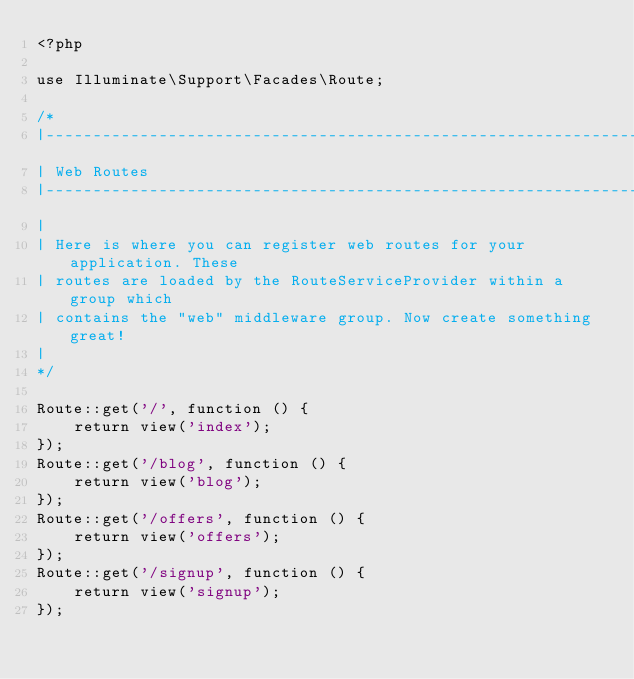<code> <loc_0><loc_0><loc_500><loc_500><_PHP_><?php

use Illuminate\Support\Facades\Route;

/*
|--------------------------------------------------------------------------
| Web Routes
|--------------------------------------------------------------------------
|
| Here is where you can register web routes for your application. These
| routes are loaded by the RouteServiceProvider within a group which
| contains the "web" middleware group. Now create something great!
|
*/

Route::get('/', function () {
    return view('index');
});
Route::get('/blog', function () {
    return view('blog');
});
Route::get('/offers', function () {
    return view('offers');
});
Route::get('/signup', function () {
    return view('signup');
});</code> 